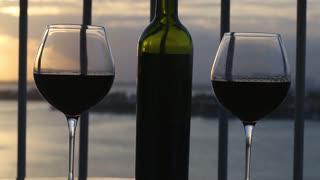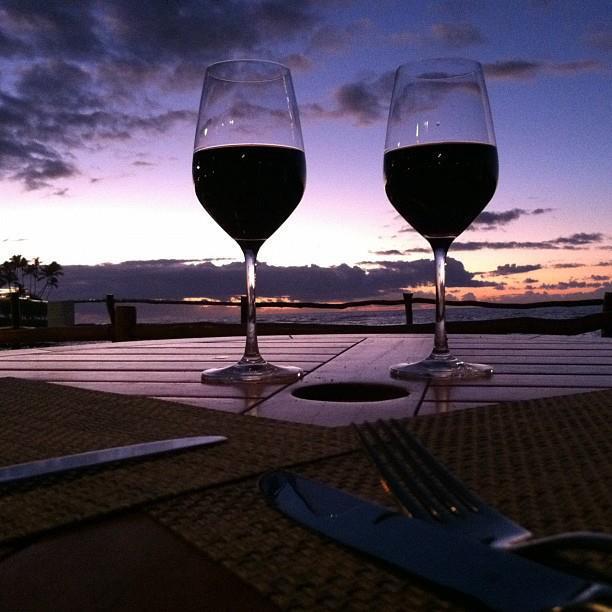The first image is the image on the left, the second image is the image on the right. For the images displayed, is the sentence "In one image, red wine is being poured into a wine glass" factually correct? Answer yes or no. No. The first image is the image on the left, the second image is the image on the right. For the images shown, is this caption "At least one image contains a wine bottle, being poured into a glass, with a sunset in the background." true? Answer yes or no. No. 